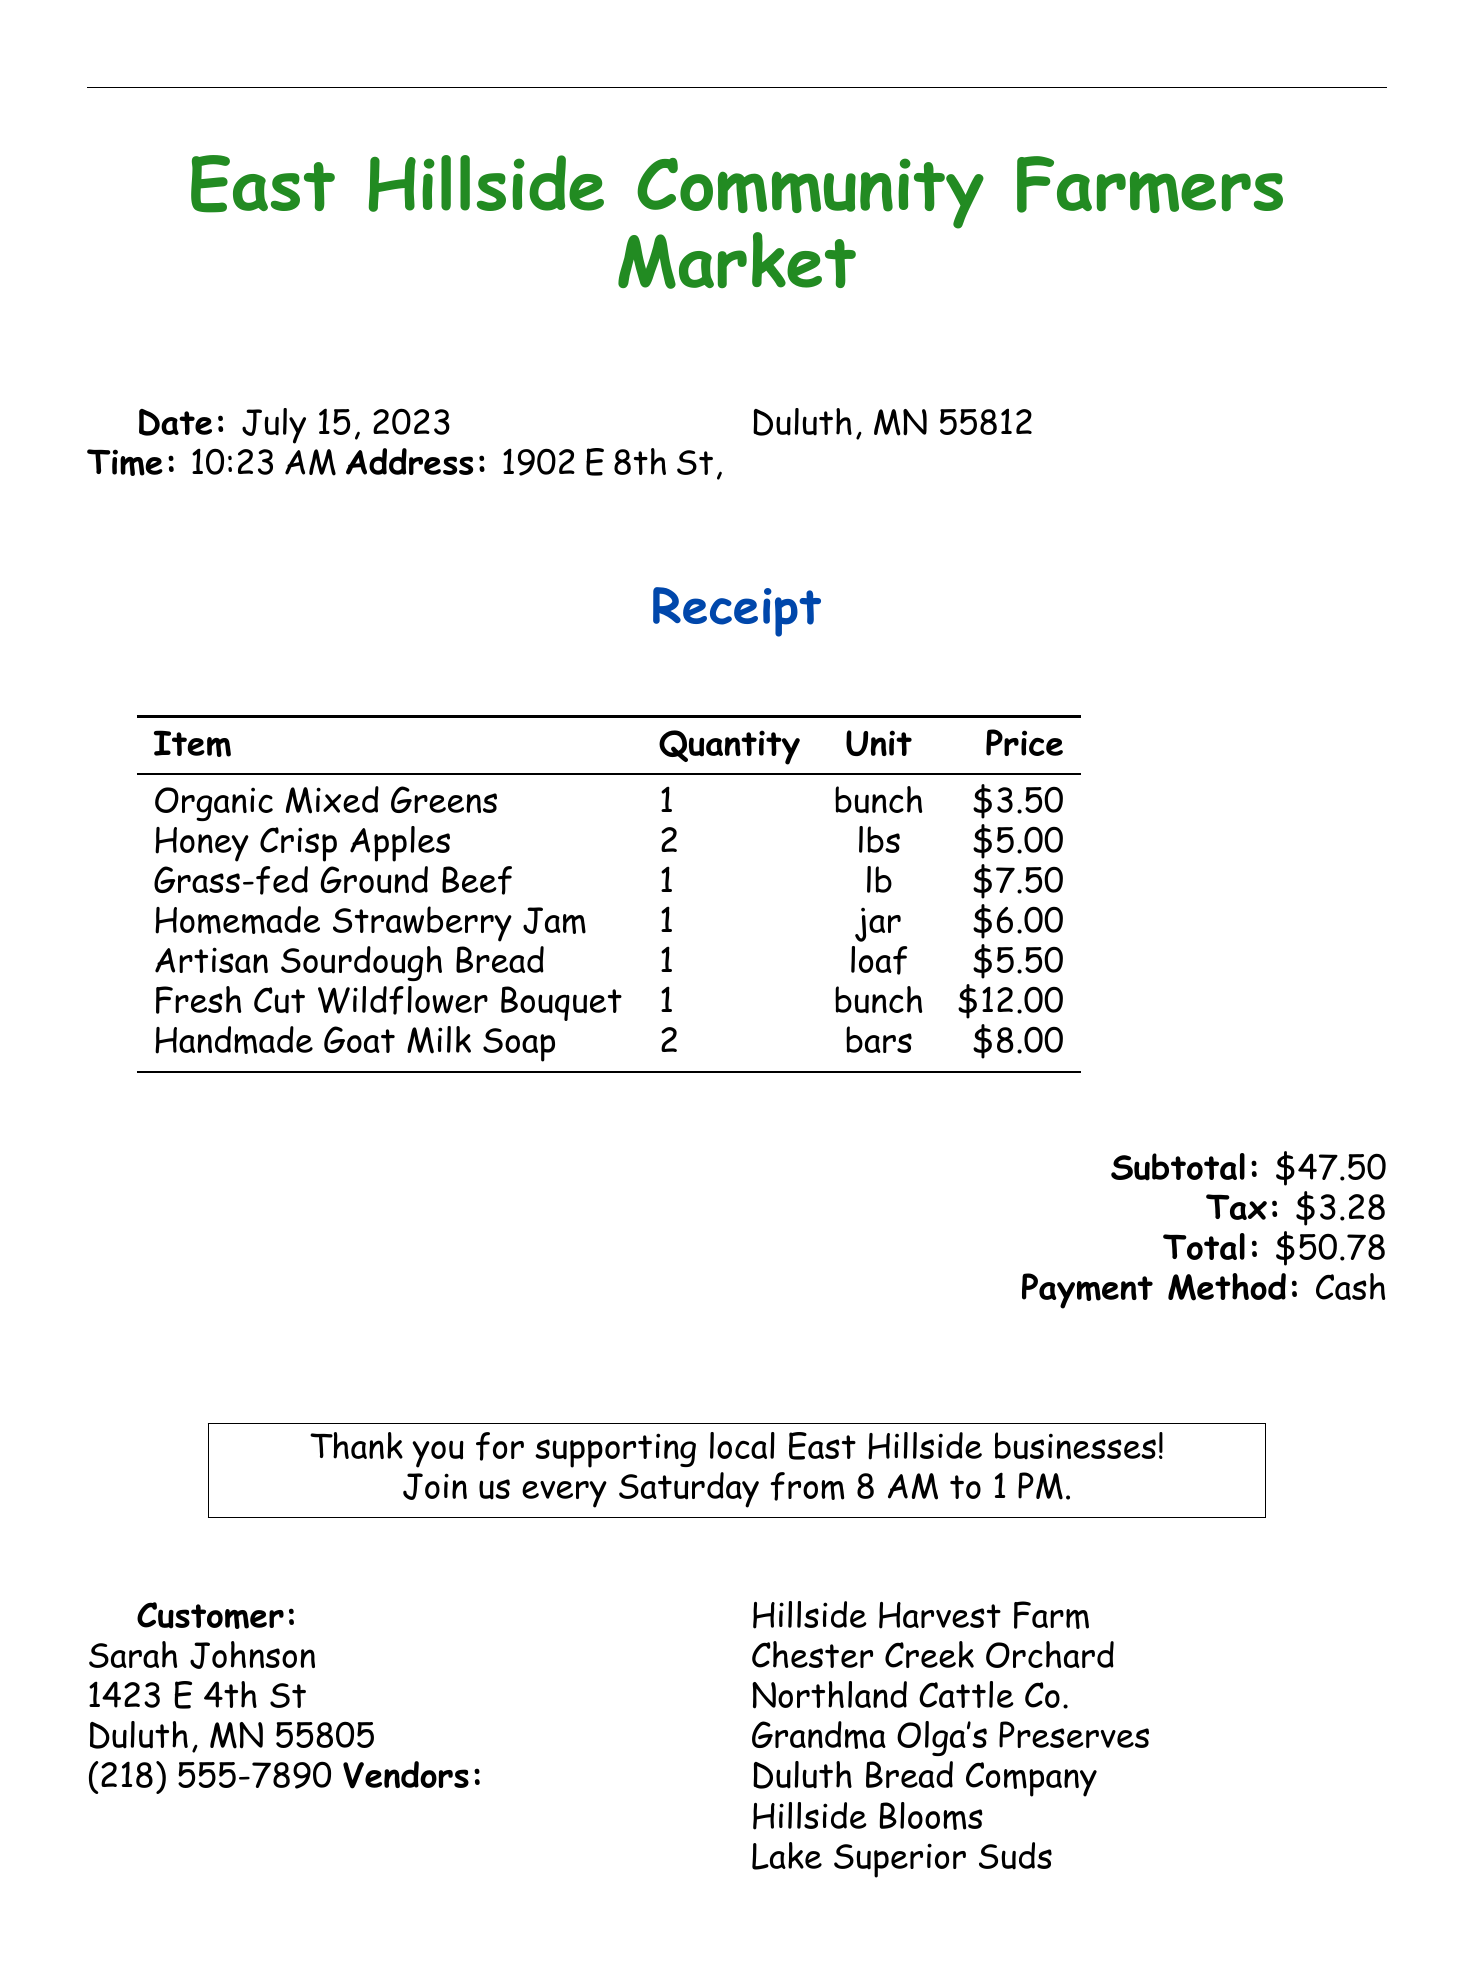What is the market name? The market name is mentioned at the top of the document.
Answer: East Hillside Community Farmers Market What is the address of the market? The address of the market is specified in the document.
Answer: 1902 E 8th St, Duluth, MN 55812 What is the date of the receipt? The date is listed in the document under the date section.
Answer: July 15, 2023 Who is the vendor for the Organic Mixed Greens? The vendor's name for each item is specified in the item details.
Answer: Hillside Harvest Farm What is the total amount paid? The total amount is calculated and shown towards the end of the document.
Answer: $50.78 How many pounds of Honey Crisp Apples were purchased? The quantity of each item is listed in the item details.
Answer: 2 lbs What is the price of the Handmade Goat Milk Soap? The price is indicated next to each item on the receipt.
Answer: $8.00 How many different vendors are listed on the receipt? The vendors are mentioned at the end of the document, requiring counting of entries.
Answer: 7 What payment method was used? The method of payment is noted in the receipt breakdown section.
Answer: Cash 